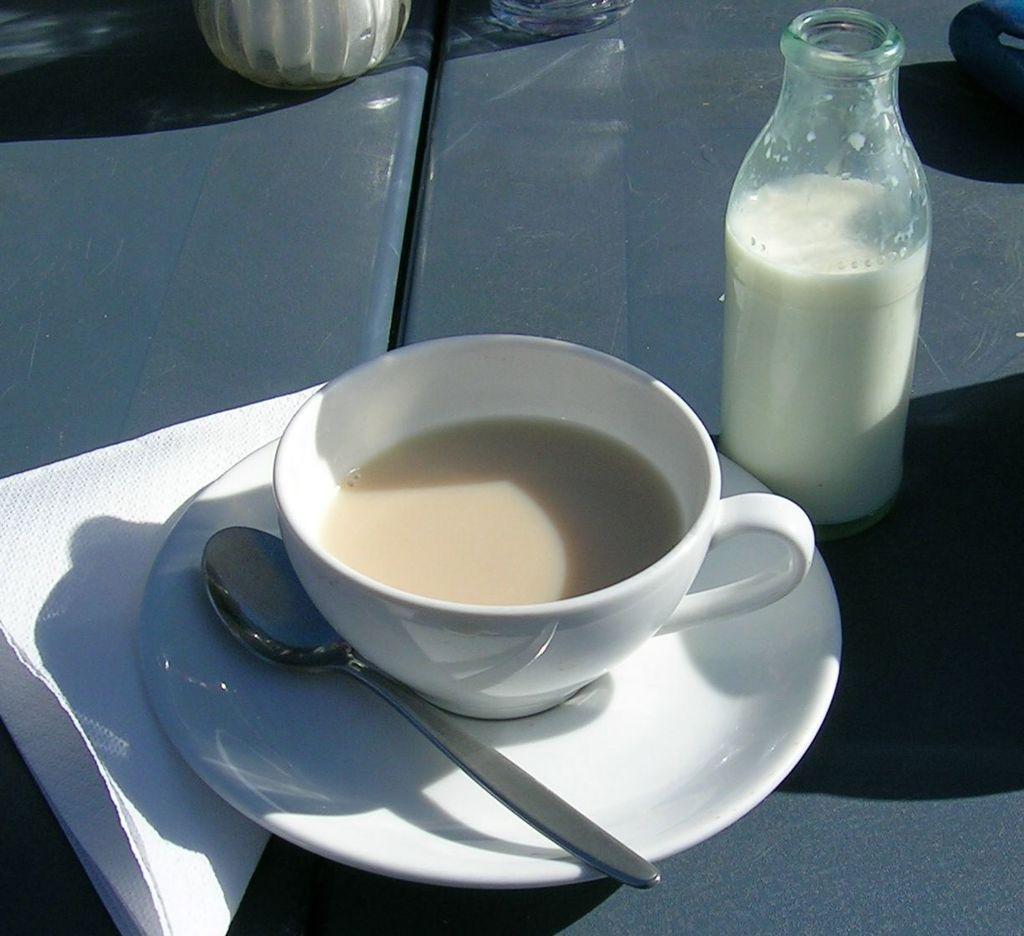What is in the cup that is visible in the image? There is a drink in the cup that is visible in the image. How is the cup supported in the image? The cup is on a saucer in the image. What utensil is placed beside the cup? There is a spoon beside the cup in the image. What type of liquid is contained in the bottle in the image? The bottle in the image contains milk. What type of honey is being served at the meeting in the image? There is no meeting or honey present in the image; it only features a cup with a drink, a saucer, a spoon, and a bottle of milk. 